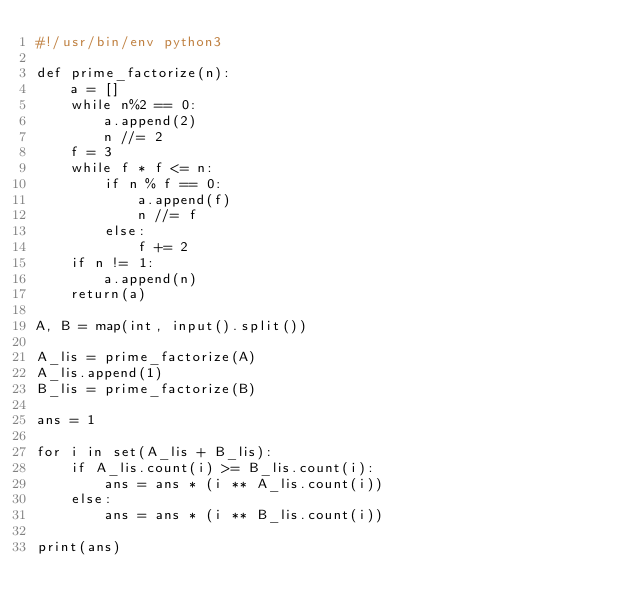Convert code to text. <code><loc_0><loc_0><loc_500><loc_500><_Python_>#!/usr/bin/env python3

def prime_factorize(n):
    a = []
    while n%2 == 0:
        a.append(2)
        n //= 2
    f = 3
    while f * f <= n:
        if n % f == 0:
            a.append(f)
            n //= f
        else:
            f += 2
    if n != 1:
        a.append(n)
    return(a)

A, B = map(int, input().split())

A_lis = prime_factorize(A)
A_lis.append(1)
B_lis = prime_factorize(B)

ans = 1

for i in set(A_lis + B_lis):
    if A_lis.count(i) >= B_lis.count(i):
        ans = ans * (i ** A_lis.count(i))
    else:
        ans = ans * (i ** B_lis.count(i))

print(ans)</code> 